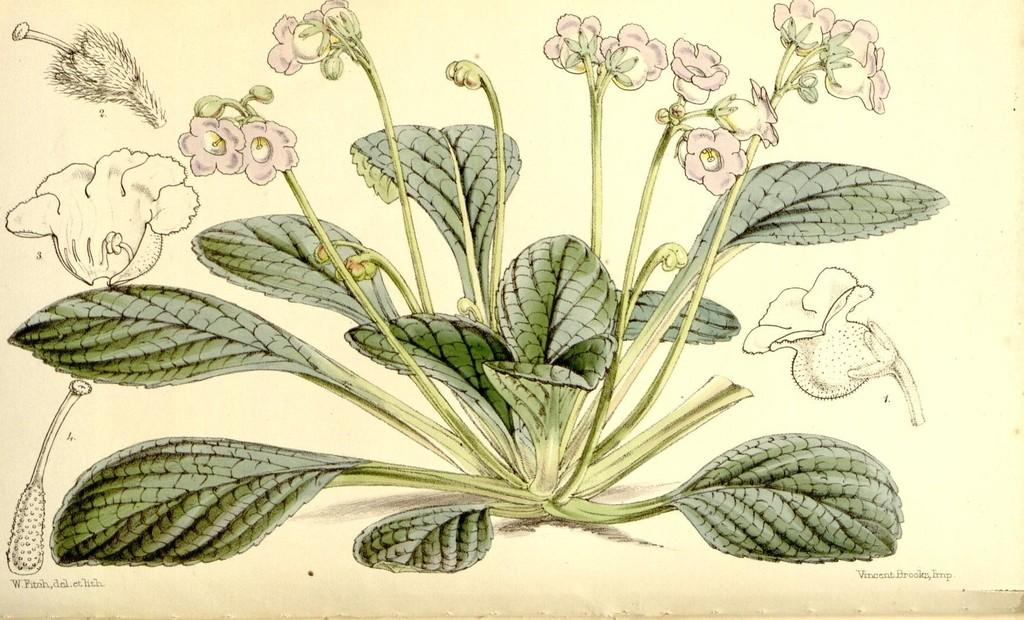What type of artwork is shown in the image? The image is a painting. What is the main subject of the painting? The painting depicts a plant. Can you describe the plant's structure? The plant has a stem, a flower, and leaves. What type of metal is used to create the peace symbol in the painting? There is no peace symbol or metal present in the painting; it features a plant with a stem, flower, and leaves. 